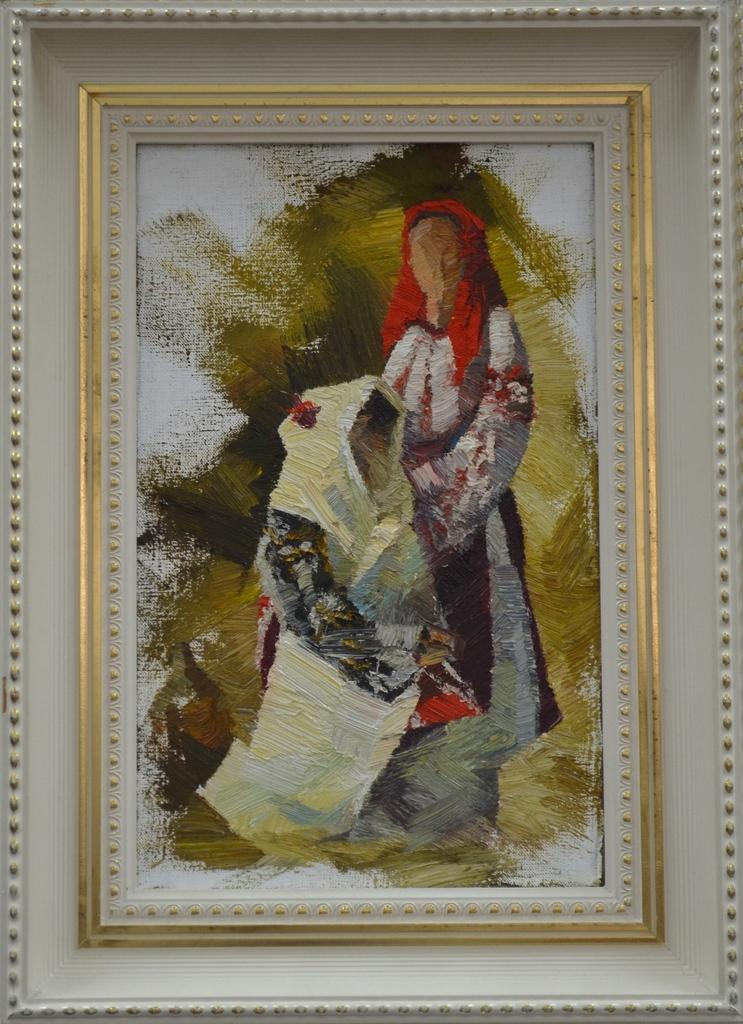What is the main subject in the image? There is a painting in the image. Can you describe the painting's appearance? The painting has a frame. How many fingers can be seen holding the painting in the image? There is no person holding the painting in the image, so no fingers can be seen. 